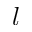<formula> <loc_0><loc_0><loc_500><loc_500>l</formula> 